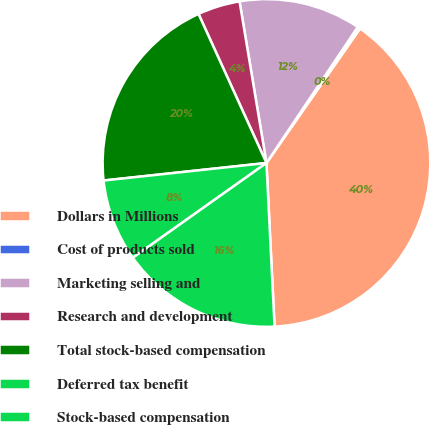<chart> <loc_0><loc_0><loc_500><loc_500><pie_chart><fcel>Dollars in Millions<fcel>Cost of products sold<fcel>Marketing selling and<fcel>Research and development<fcel>Total stock-based compensation<fcel>Deferred tax benefit<fcel>Stock-based compensation<nl><fcel>39.54%<fcel>0.26%<fcel>12.04%<fcel>4.18%<fcel>19.9%<fcel>8.11%<fcel>15.97%<nl></chart> 